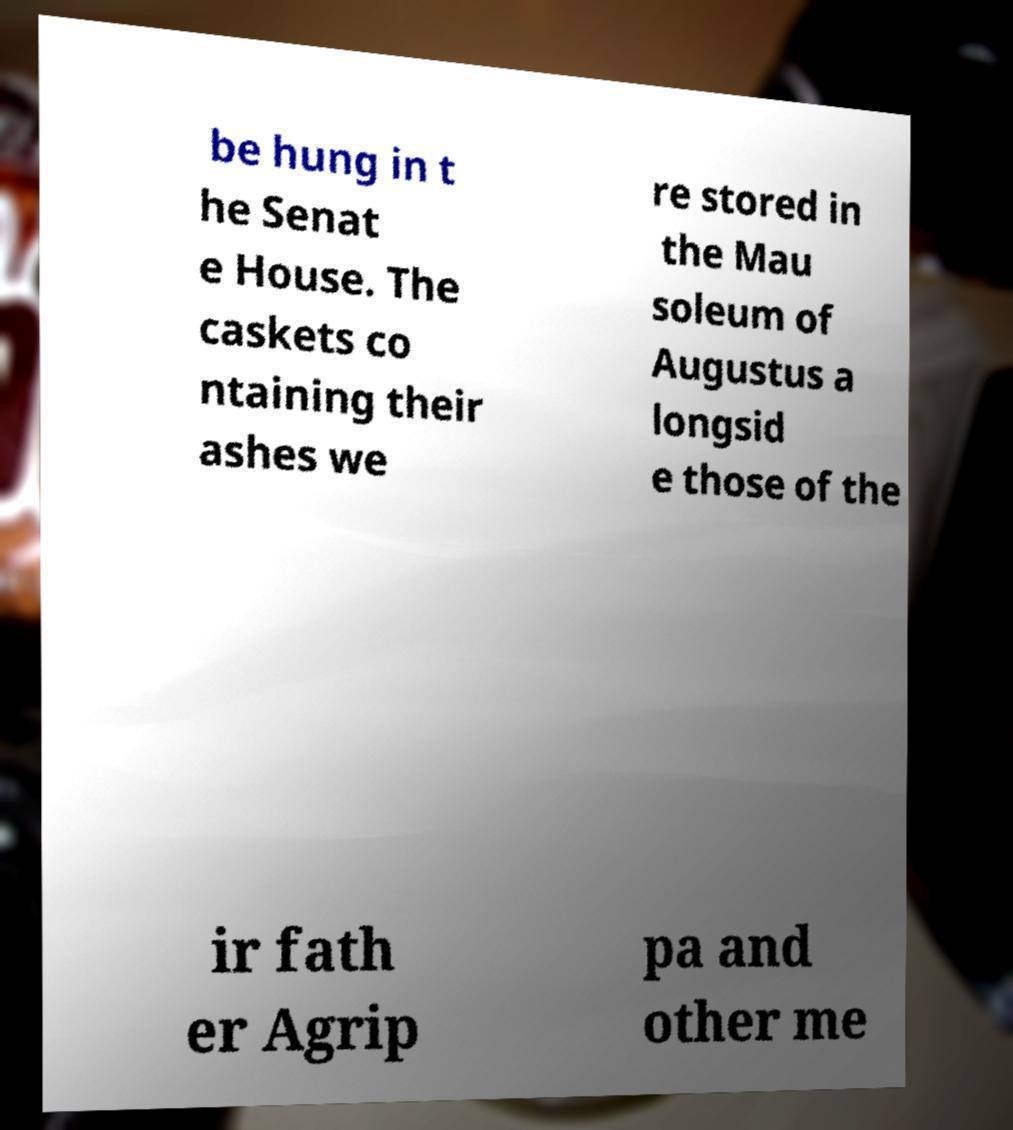Can you accurately transcribe the text from the provided image for me? be hung in t he Senat e House. The caskets co ntaining their ashes we re stored in the Mau soleum of Augustus a longsid e those of the ir fath er Agrip pa and other me 